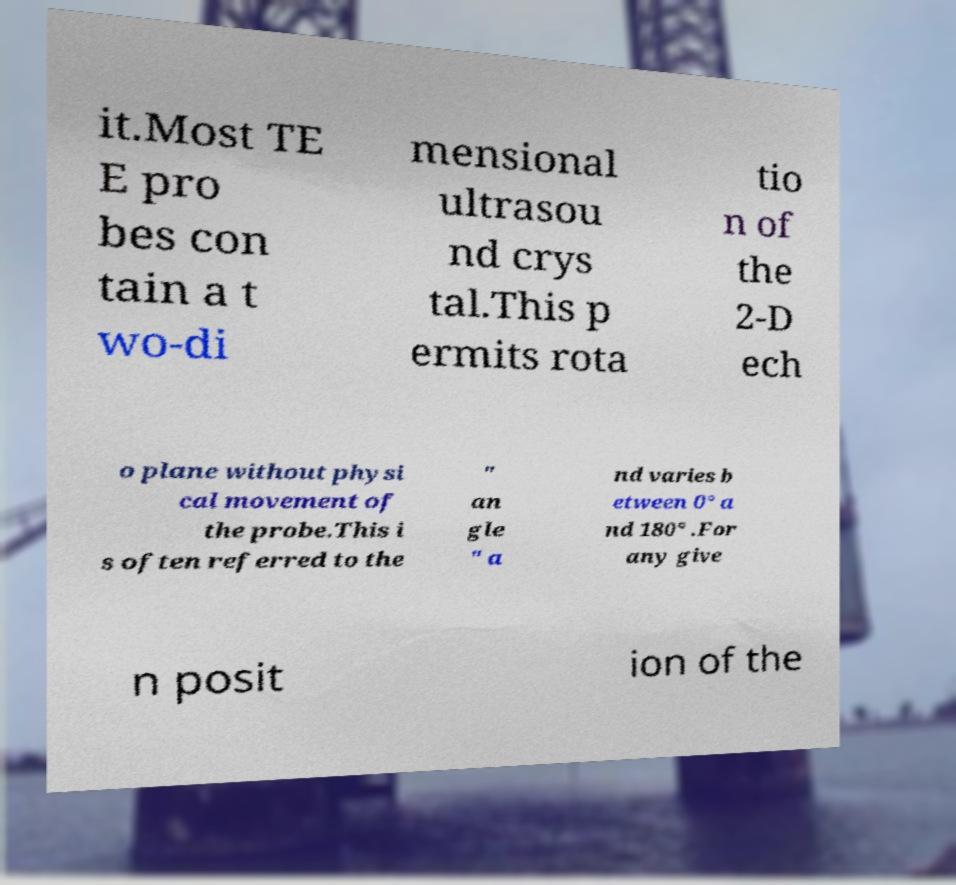There's text embedded in this image that I need extracted. Can you transcribe it verbatim? it.Most TE E pro bes con tain a t wo-di mensional ultrasou nd crys tal.This p ermits rota tio n of the 2-D ech o plane without physi cal movement of the probe.This i s often referred to the " an gle " a nd varies b etween 0° a nd 180° .For any give n posit ion of the 